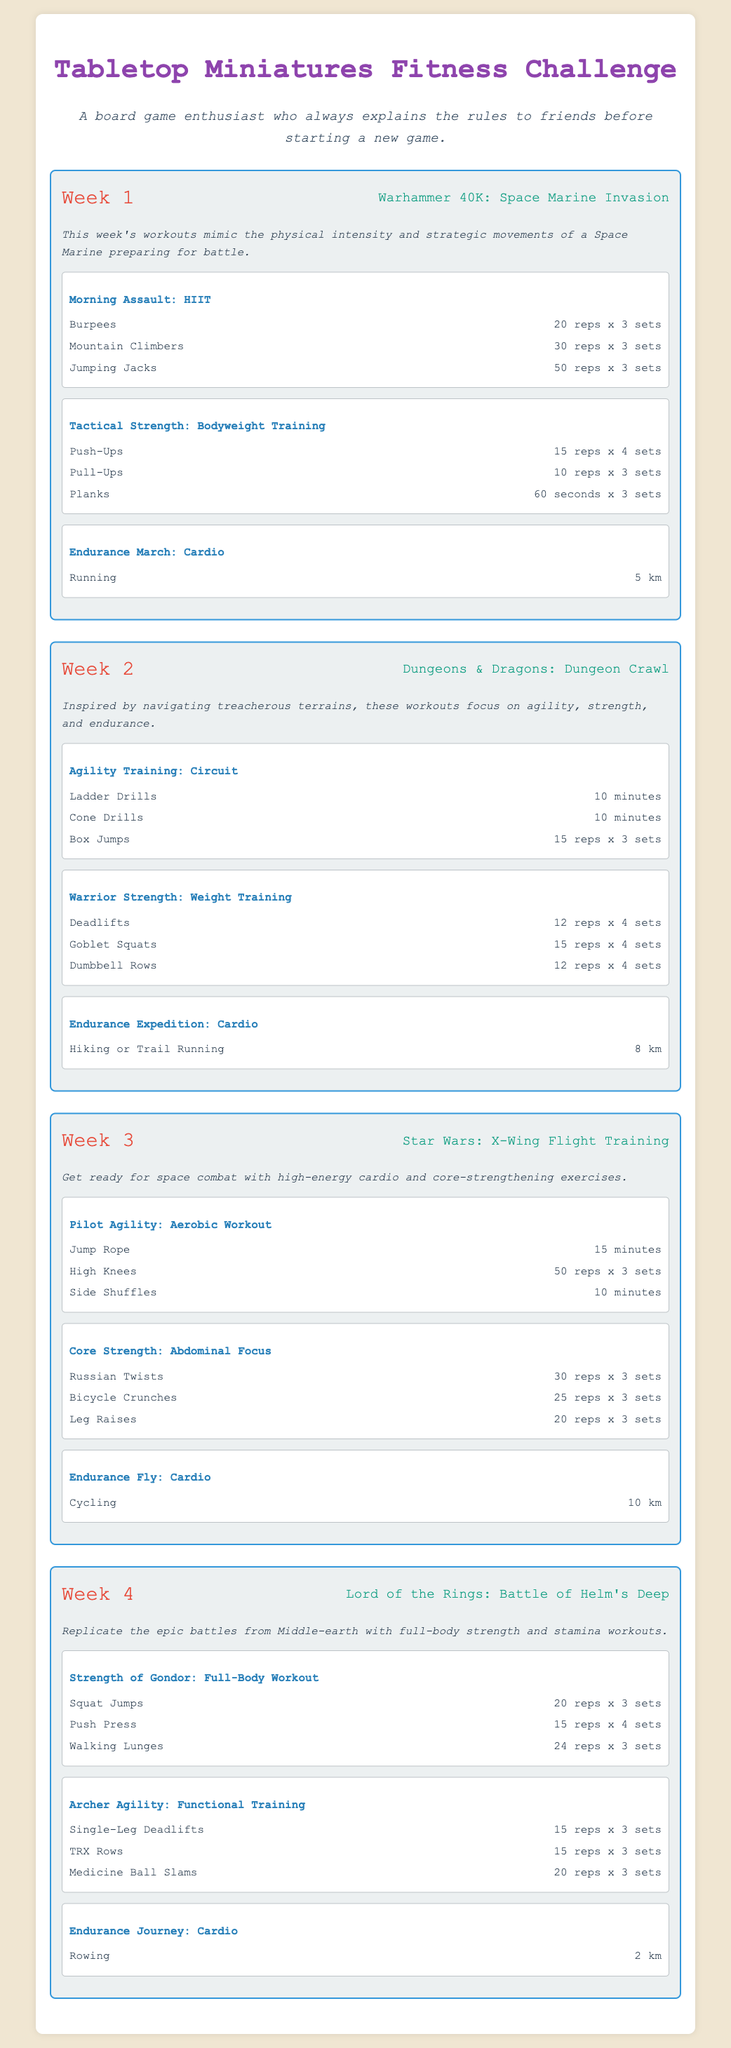What is the title of the workout plan? The title appears at the top of the document, indicating the focus of the workouts.
Answer: Tabletop Miniatures Fitness Challenge How many weeks are included in the workout plan? The document outlines workouts structured across different weeks, indicating the total weeks covered.
Answer: 4 What is the theme for Week 2? Each week has a specific theme connected to a board game, which reflects on the workouts.
Answer: Dungeons & Dragons: Dungeon Crawl How many exercises are in "Morning Assault: HIIT"? Each workout typically contains several exercises listed under its name, showing the structure of daily routines.
Answer: 3 What is the total distance to be run in Week 1? Week 1 includes one cardio workout which specifies the distance to cover.
Answer: 5 km What type of training is "Tactical Strength"? Each workout is categorized by its focus or type, indicating its nature and approach to fitness.
Answer: Bodyweight Training What is the rep range for "Goblet Squats"? Exercises have specific repetition counts, which are crucial for understanding workout intensity.
Answer: 15 reps x 4 sets What cardio exercise is included in "Endurance Expedition"? Cardio workouts are specified, which focus on increasing stamina and cardiovascular health.
Answer: Hiking or Trail Running 